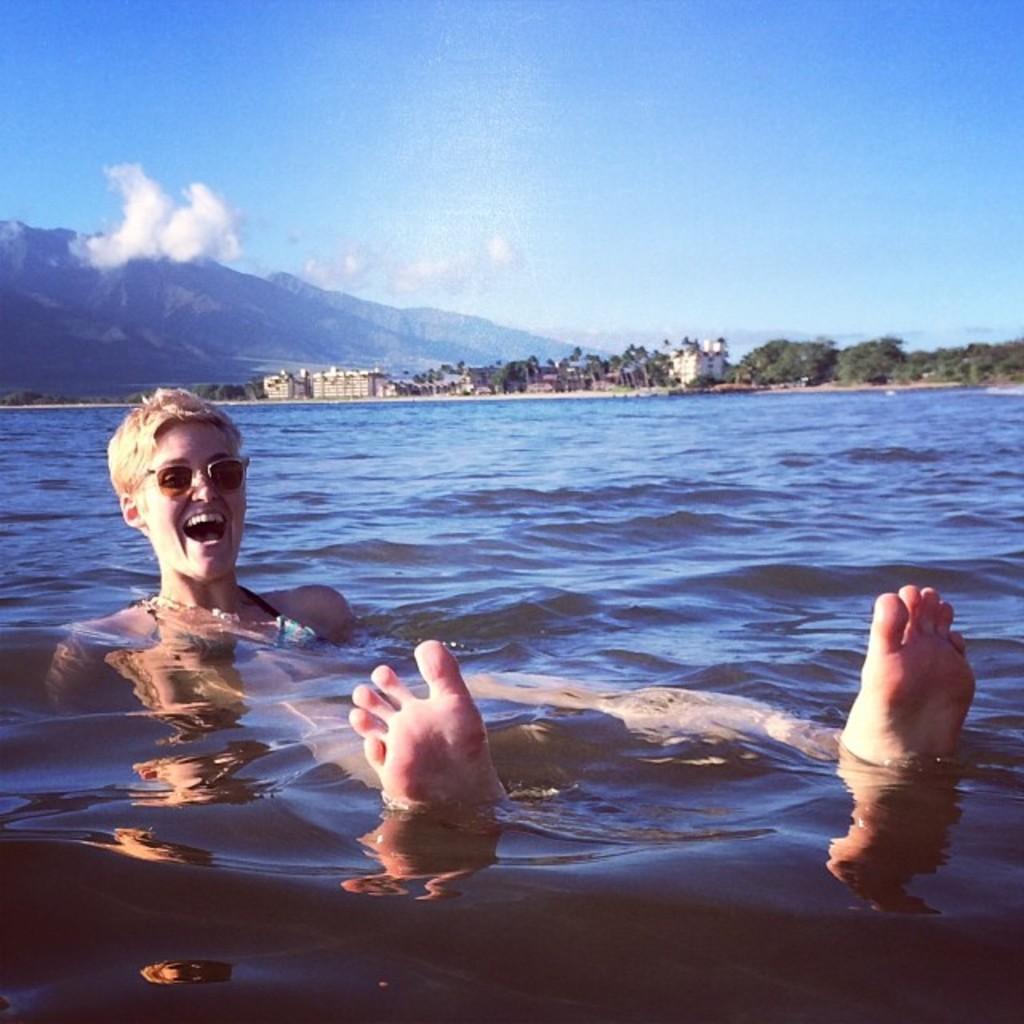Please provide a concise description of this image. In this image I can see the water and a woman in the water. In the background I can see few trees, few buildings, few mountains and the sky. 